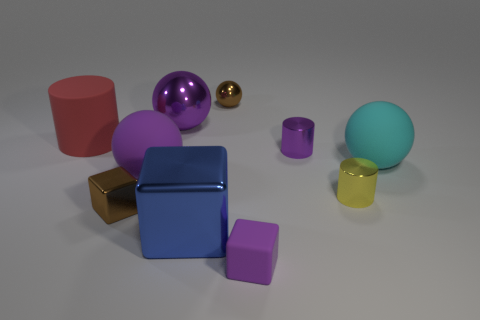What is the material of the small brown cube that is to the left of the object to the right of the small yellow metal cylinder?
Provide a succinct answer. Metal. Do the purple matte thing that is behind the large blue thing and the purple shiny object that is left of the big blue metallic cube have the same shape?
Offer a terse response. Yes. What size is the cylinder that is both behind the small yellow metal object and to the right of the red rubber cylinder?
Your answer should be compact. Small. What number of other things are there of the same color as the matte block?
Offer a very short reply. 3. Are the tiny object on the left side of the big blue metallic thing and the big red thing made of the same material?
Your answer should be compact. No. Are there fewer brown shiny balls in front of the large purple matte object than large matte things to the left of the small yellow cylinder?
Your answer should be very brief. Yes. What material is the other big sphere that is the same color as the big metal sphere?
Offer a very short reply. Rubber. There is a small brown ball left of the rubber thing that is in front of the large blue shiny thing; how many small brown things are to the left of it?
Your response must be concise. 1. There is a red thing; how many things are on the right side of it?
Give a very brief answer. 9. What number of cylinders have the same material as the small sphere?
Provide a succinct answer. 2. 